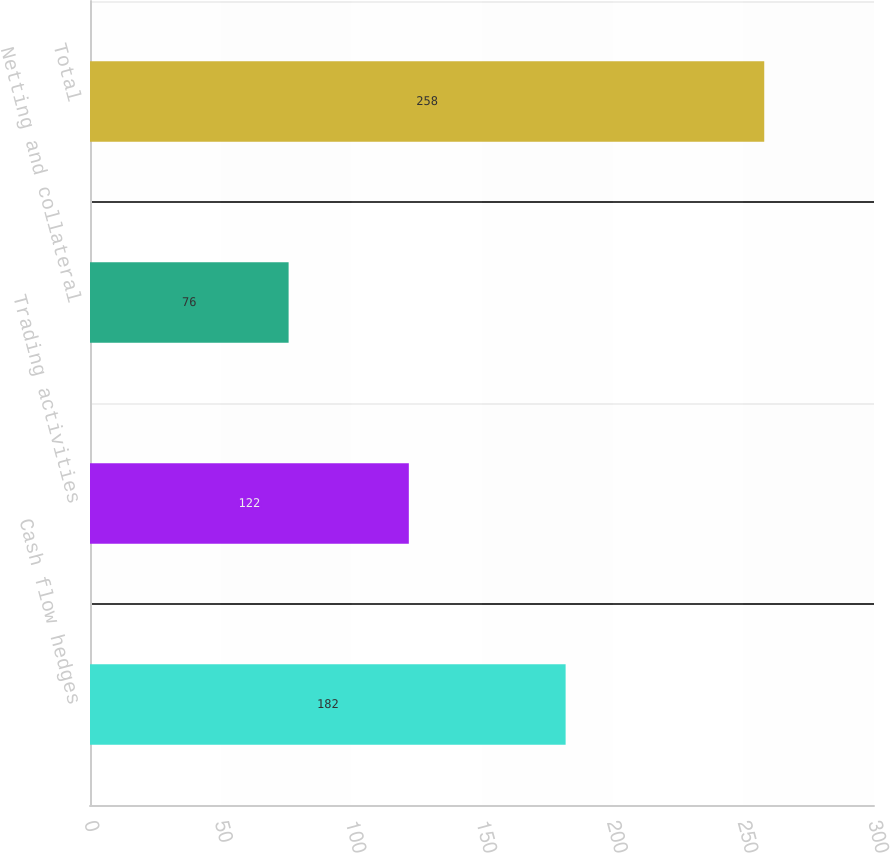Convert chart to OTSL. <chart><loc_0><loc_0><loc_500><loc_500><bar_chart><fcel>Cash flow hedges<fcel>Trading activities<fcel>Netting and collateral<fcel>Total<nl><fcel>182<fcel>122<fcel>76<fcel>258<nl></chart> 